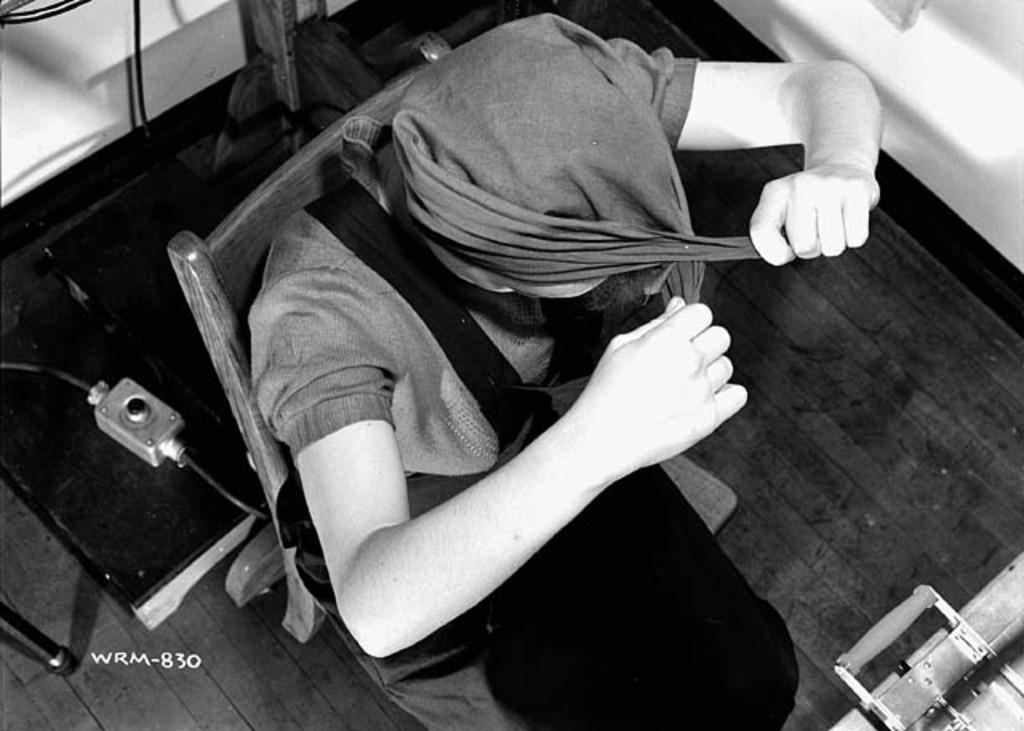What is the color scheme of the image? The image is black and white. What is the person in the image doing? The person is sitting on a chair in the image. What can be seen behind the person? There are items visible behind the person. What is the background of the image? There is a wall behind the person and items. How does the person attempt to comb their hair in the image? There is no comb or hair visible in the image, so it is not possible to determine if the person is attempting to comb their hair. 